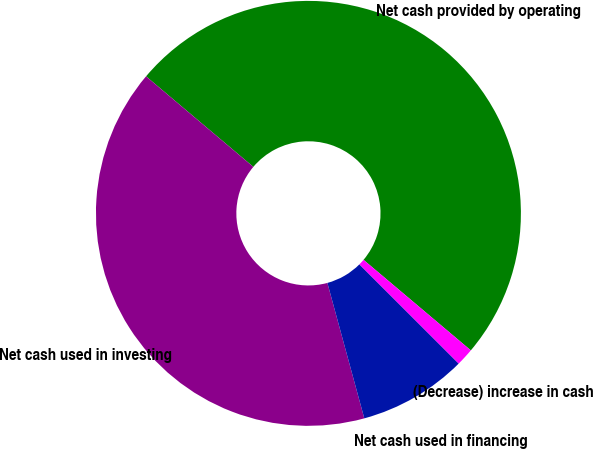<chart> <loc_0><loc_0><loc_500><loc_500><pie_chart><fcel>Net cash provided by operating<fcel>Net cash used in investing<fcel>Net cash used in financing<fcel>(Decrease) increase in cash<nl><fcel>50.0%<fcel>40.39%<fcel>8.27%<fcel>1.34%<nl></chart> 